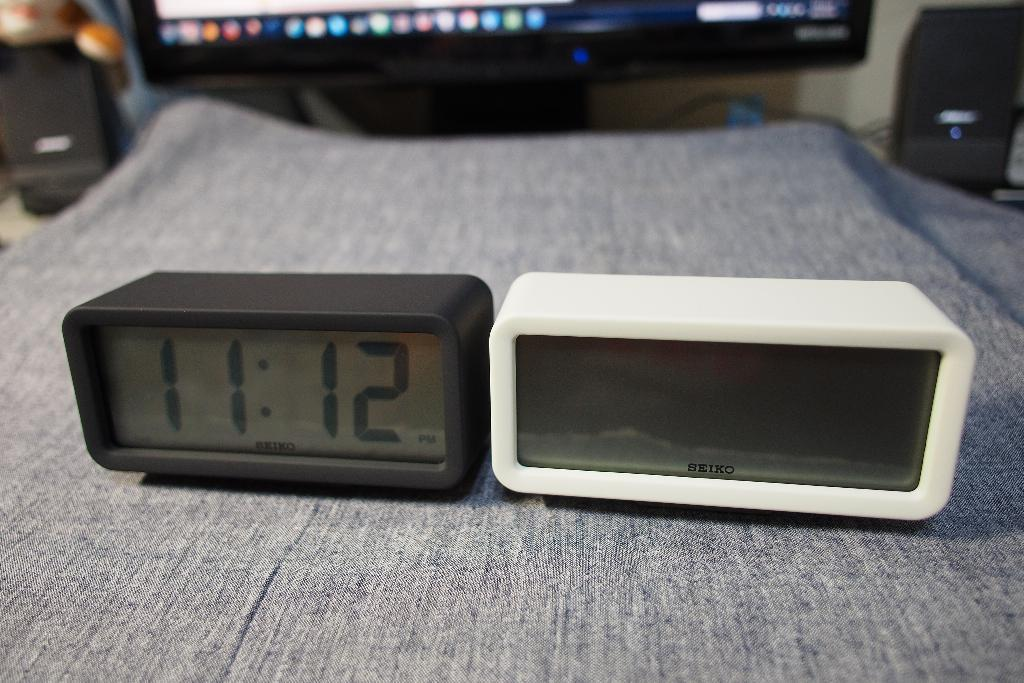<image>
Render a clear and concise summary of the photo. A digital clock reads the time as 11:12. 